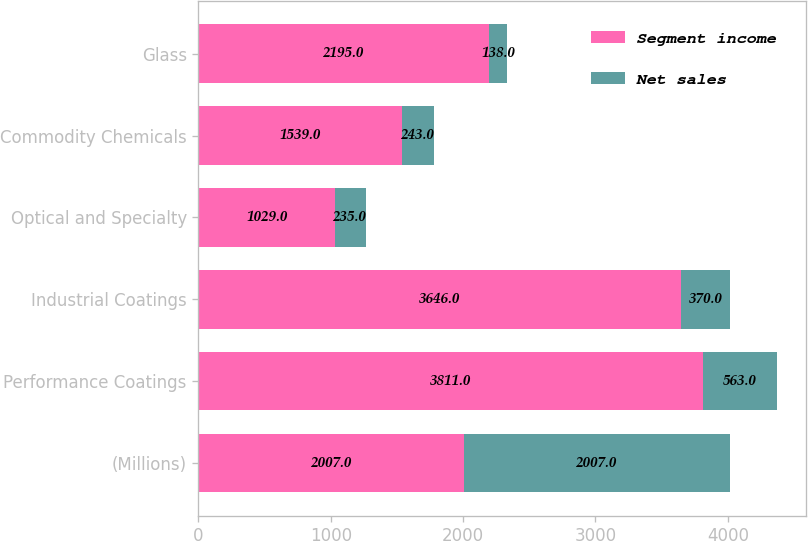Convert chart. <chart><loc_0><loc_0><loc_500><loc_500><stacked_bar_chart><ecel><fcel>(Millions)<fcel>Performance Coatings<fcel>Industrial Coatings<fcel>Optical and Specialty<fcel>Commodity Chemicals<fcel>Glass<nl><fcel>Segment income<fcel>2007<fcel>3811<fcel>3646<fcel>1029<fcel>1539<fcel>2195<nl><fcel>Net sales<fcel>2007<fcel>563<fcel>370<fcel>235<fcel>243<fcel>138<nl></chart> 